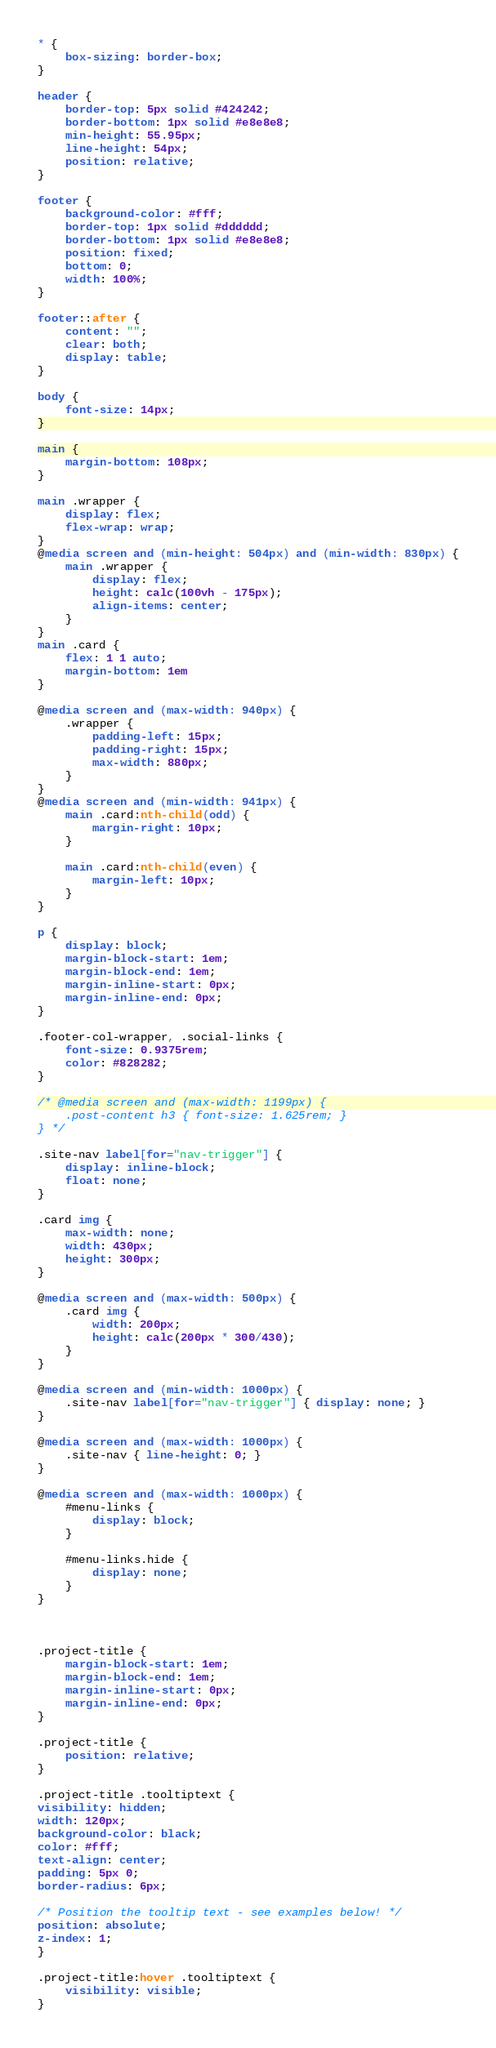Convert code to text. <code><loc_0><loc_0><loc_500><loc_500><_CSS_>* {
    box-sizing: border-box;
}

header {
    border-top: 5px solid #424242;
    border-bottom: 1px solid #e8e8e8;
    min-height: 55.95px;
    line-height: 54px;
    position: relative;
}

footer {
    background-color: #fff;
    border-top: 1px solid #dddddd;
    border-bottom: 1px solid #e8e8e8;
    position: fixed;
    bottom: 0;
    width: 100%;
}

footer::after {
    content: "";
    clear: both;
    display: table;
}

body {
    font-size: 14px;
}

main {
    margin-bottom: 108px;
}

main .wrapper {
    display: flex;
    flex-wrap: wrap;
}
@media screen and (min-height: 504px) and (min-width: 830px) {
    main .wrapper {
        display: flex;
        height: calc(100vh - 175px);
        align-items: center;
    }
}
main .card {
    flex: 1 1 auto;
    margin-bottom: 1em
}

@media screen and (max-width: 940px) {
    .wrapper {
        padding-left: 15px;
        padding-right: 15px;
        max-width: 880px;
    }
}
@media screen and (min-width: 941px) {
    main .card:nth-child(odd) {
        margin-right: 10px;
    }

    main .card:nth-child(even) {
        margin-left: 10px;
    }
}

p {
    display: block;
    margin-block-start: 1em;
    margin-block-end: 1em;
    margin-inline-start: 0px;
    margin-inline-end: 0px;
}

.footer-col-wrapper, .social-links {
    font-size: 0.9375rem;
    color: #828282;
}

/* @media screen and (max-width: 1199px) {
    .post-content h3 { font-size: 1.625rem; }
} */

.site-nav label[for="nav-trigger"] {
    display: inline-block;
    float: none;
}

.card img {
    max-width: none;
    width: 430px;
    height: 300px;
}

@media screen and (max-width: 500px) {
    .card img {
        width: 200px;
        height: calc(200px * 300/430);
    }
}

@media screen and (min-width: 1000px) {
    .site-nav label[for="nav-trigger"] { display: none; }
}

@media screen and (max-width: 1000px) {
    .site-nav { line-height: 0; }
}

@media screen and (max-width: 1000px) {
    #menu-links {
        display: block;
    }

    #menu-links.hide {
        display: none;
    }
}



.project-title {
    margin-block-start: 1em;
    margin-block-end: 1em;
    margin-inline-start: 0px;
    margin-inline-end: 0px;
}

.project-title {
    position: relative;
}

.project-title .tooltiptext {
visibility: hidden;
width: 120px;
background-color: black;
color: #fff;
text-align: center;
padding: 5px 0;
border-radius: 6px;

/* Position the tooltip text - see examples below! */
position: absolute;
z-index: 1;
}

.project-title:hover .tooltiptext {
    visibility: visible;
}</code> 